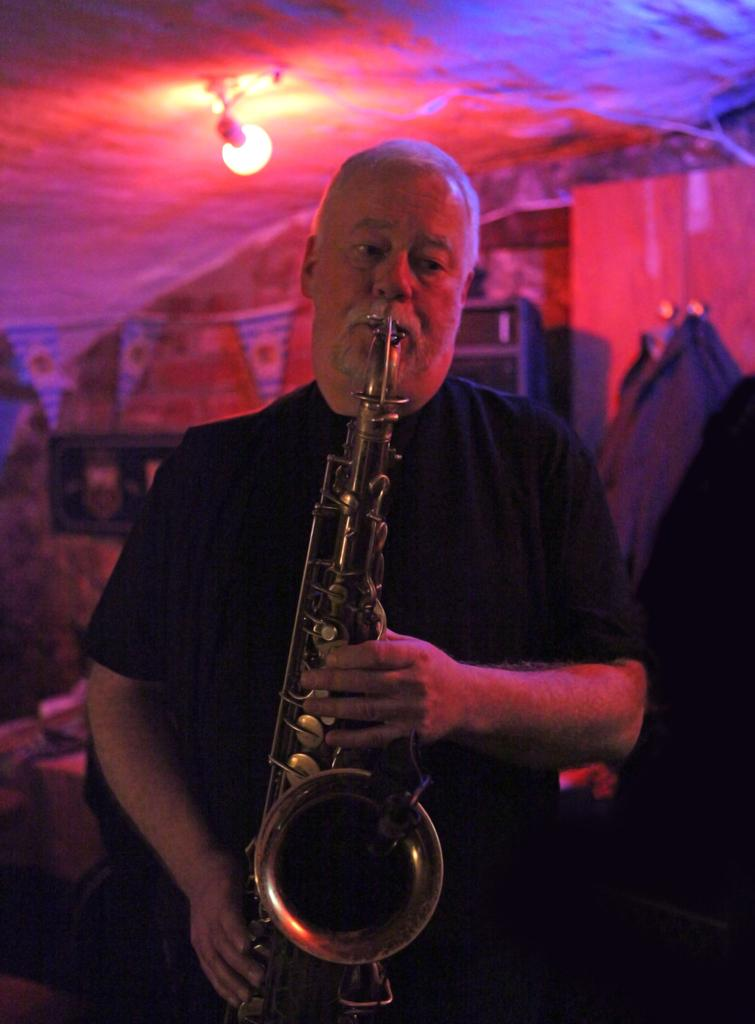Who is the person in the image? There is a man in the image. What is the man holding in the image? The man is holding a saxophone. Can you describe the background of the image? The background of the image is blurred. What can be seen in the background of the image? There are lights visible in the background. What type of arch can be seen in the image? There is no arch present in the image. How many necks are visible in the image? There are no necks visible in the image. 